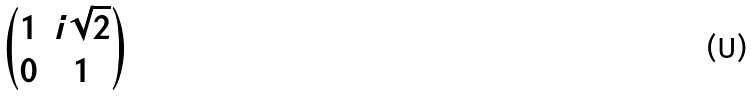Convert formula to latex. <formula><loc_0><loc_0><loc_500><loc_500>\begin{pmatrix} 1 & i \sqrt { 2 } \\ 0 & 1 \end{pmatrix}</formula> 